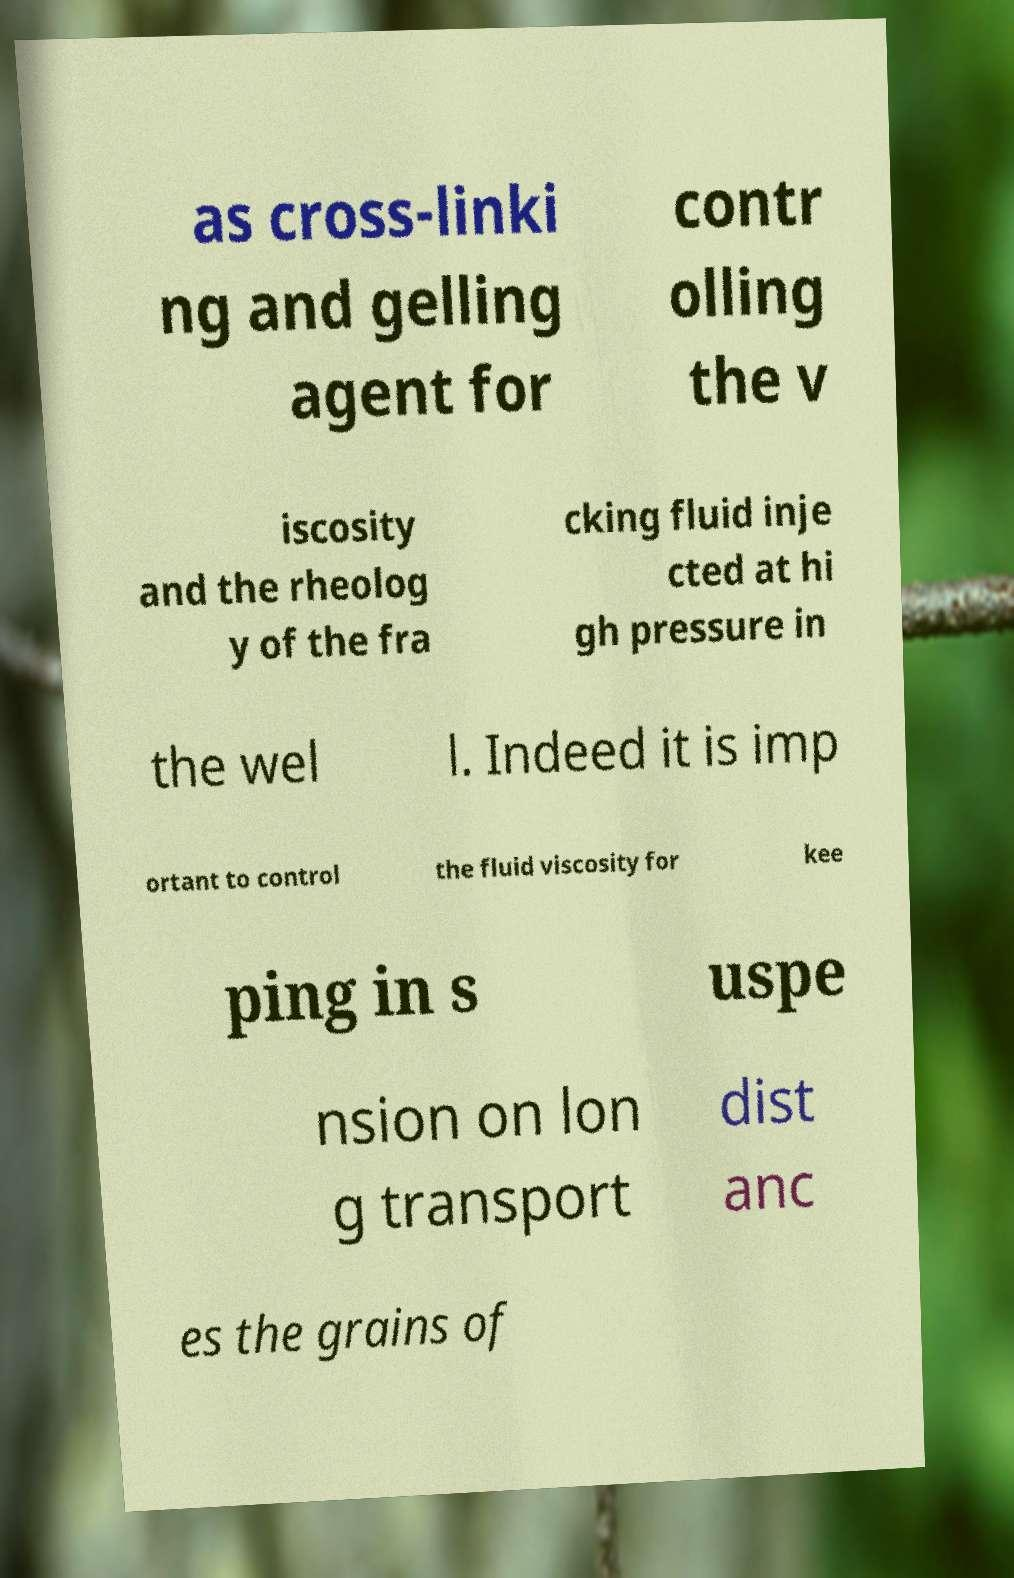Could you extract and type out the text from this image? as cross-linki ng and gelling agent for contr olling the v iscosity and the rheolog y of the fra cking fluid inje cted at hi gh pressure in the wel l. Indeed it is imp ortant to control the fluid viscosity for kee ping in s uspe nsion on lon g transport dist anc es the grains of 